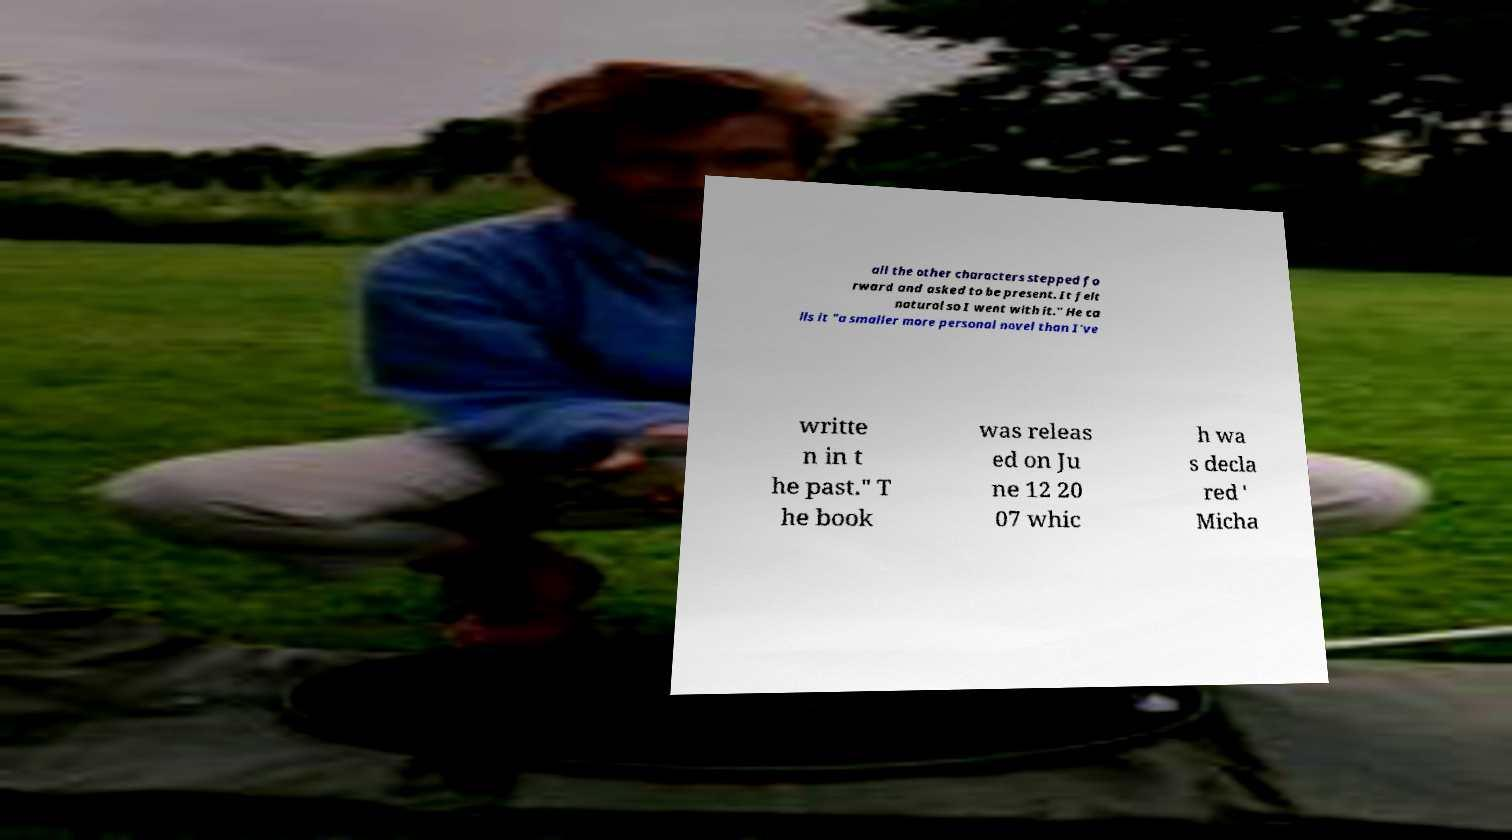There's text embedded in this image that I need extracted. Can you transcribe it verbatim? all the other characters stepped fo rward and asked to be present. It felt natural so I went with it." He ca lls it "a smaller more personal novel than I've writte n in t he past." T he book was releas ed on Ju ne 12 20 07 whic h wa s decla red ' Micha 